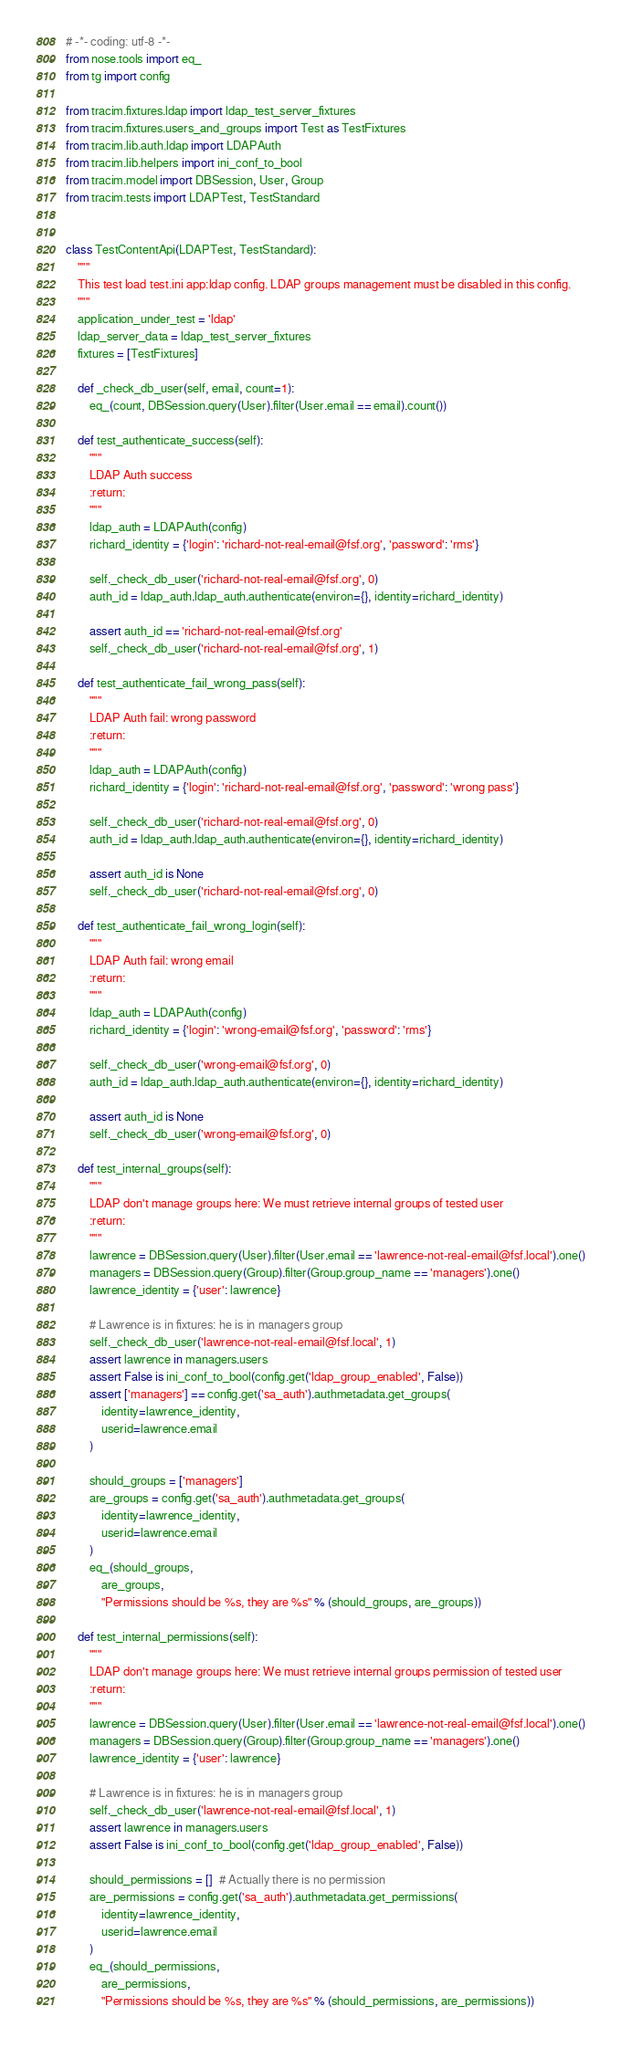<code> <loc_0><loc_0><loc_500><loc_500><_Python_># -*- coding: utf-8 -*-
from nose.tools import eq_
from tg import config

from tracim.fixtures.ldap import ldap_test_server_fixtures
from tracim.fixtures.users_and_groups import Test as TestFixtures
from tracim.lib.auth.ldap import LDAPAuth
from tracim.lib.helpers import ini_conf_to_bool
from tracim.model import DBSession, User, Group
from tracim.tests import LDAPTest, TestStandard


class TestContentApi(LDAPTest, TestStandard):
    """
    This test load test.ini app:ldap config. LDAP groups management must be disabled in this config.
    """
    application_under_test = 'ldap'
    ldap_server_data = ldap_test_server_fixtures
    fixtures = [TestFixtures]

    def _check_db_user(self, email, count=1):
        eq_(count, DBSession.query(User).filter(User.email == email).count())

    def test_authenticate_success(self):
        """
        LDAP Auth success
        :return:
        """
        ldap_auth = LDAPAuth(config)
        richard_identity = {'login': 'richard-not-real-email@fsf.org', 'password': 'rms'}

        self._check_db_user('richard-not-real-email@fsf.org', 0)
        auth_id = ldap_auth.ldap_auth.authenticate(environ={}, identity=richard_identity)

        assert auth_id == 'richard-not-real-email@fsf.org'
        self._check_db_user('richard-not-real-email@fsf.org', 1)

    def test_authenticate_fail_wrong_pass(self):
        """
        LDAP Auth fail: wrong password
        :return:
        """
        ldap_auth = LDAPAuth(config)
        richard_identity = {'login': 'richard-not-real-email@fsf.org', 'password': 'wrong pass'}

        self._check_db_user('richard-not-real-email@fsf.org', 0)
        auth_id = ldap_auth.ldap_auth.authenticate(environ={}, identity=richard_identity)

        assert auth_id is None
        self._check_db_user('richard-not-real-email@fsf.org', 0)

    def test_authenticate_fail_wrong_login(self):
        """
        LDAP Auth fail: wrong email
        :return:
        """
        ldap_auth = LDAPAuth(config)
        richard_identity = {'login': 'wrong-email@fsf.org', 'password': 'rms'}

        self._check_db_user('wrong-email@fsf.org', 0)
        auth_id = ldap_auth.ldap_auth.authenticate(environ={}, identity=richard_identity)

        assert auth_id is None
        self._check_db_user('wrong-email@fsf.org', 0)

    def test_internal_groups(self):
        """
        LDAP don't manage groups here: We must retrieve internal groups of tested user
        :return:
        """
        lawrence = DBSession.query(User).filter(User.email == 'lawrence-not-real-email@fsf.local').one()
        managers = DBSession.query(Group).filter(Group.group_name == 'managers').one()
        lawrence_identity = {'user': lawrence}

        # Lawrence is in fixtures: he is in managers group
        self._check_db_user('lawrence-not-real-email@fsf.local', 1)
        assert lawrence in managers.users
        assert False is ini_conf_to_bool(config.get('ldap_group_enabled', False))
        assert ['managers'] == config.get('sa_auth').authmetadata.get_groups(
            identity=lawrence_identity,
            userid=lawrence.email
        )

        should_groups = ['managers']
        are_groups = config.get('sa_auth').authmetadata.get_groups(
            identity=lawrence_identity,
            userid=lawrence.email
        )
        eq_(should_groups,
            are_groups,
            "Permissions should be %s, they are %s" % (should_groups, are_groups))

    def test_internal_permissions(self):
        """
        LDAP don't manage groups here: We must retrieve internal groups permission of tested user
        :return:
        """
        lawrence = DBSession.query(User).filter(User.email == 'lawrence-not-real-email@fsf.local').one()
        managers = DBSession.query(Group).filter(Group.group_name == 'managers').one()
        lawrence_identity = {'user': lawrence}

        # Lawrence is in fixtures: he is in managers group
        self._check_db_user('lawrence-not-real-email@fsf.local', 1)
        assert lawrence in managers.users
        assert False is ini_conf_to_bool(config.get('ldap_group_enabled', False))

        should_permissions = []  # Actually there is no permission
        are_permissions = config.get('sa_auth').authmetadata.get_permissions(
            identity=lawrence_identity,
            userid=lawrence.email
        )
        eq_(should_permissions,
            are_permissions,
            "Permissions should be %s, they are %s" % (should_permissions, are_permissions))

</code> 